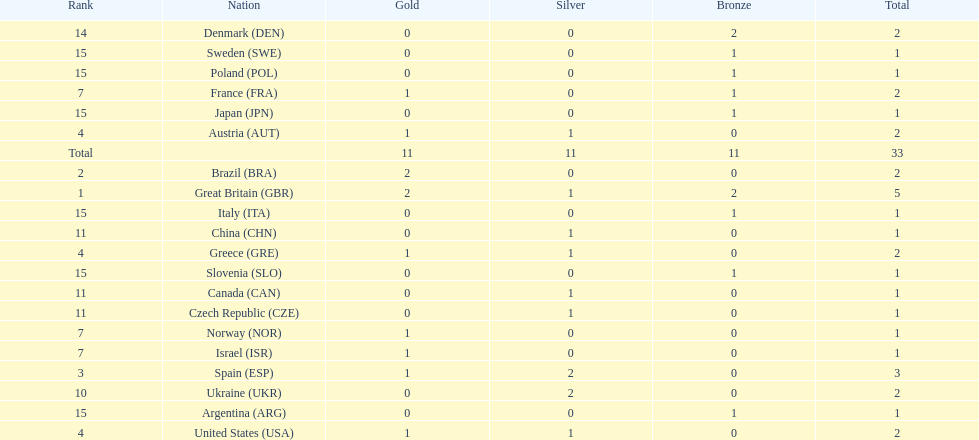What was the number of silver medals won by ukraine? 2. 